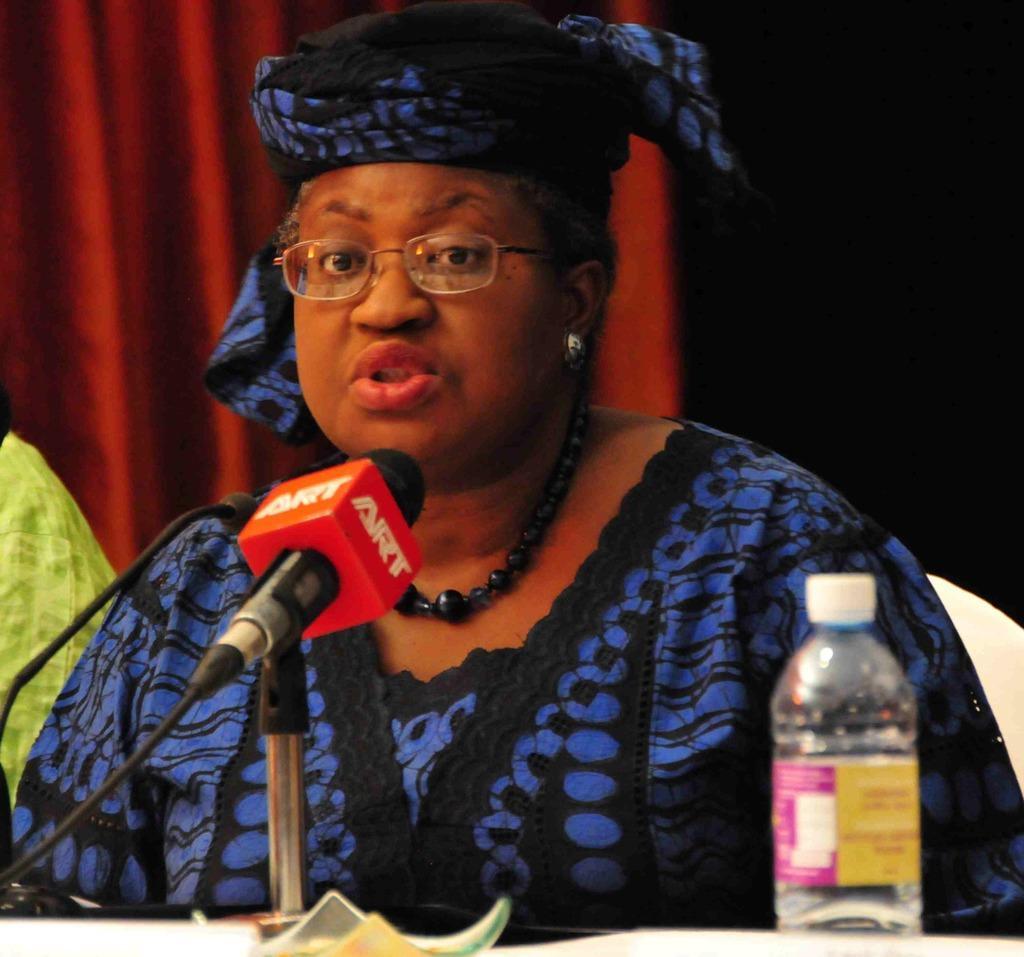Can you describe this image briefly? In this image In the middle there is a woman she wear blue dress she is speaking she is sitting on the chair. In the middle there is a mic and bottle. In the background there is a curtain. 